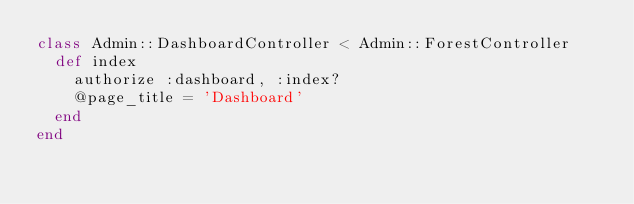Convert code to text. <code><loc_0><loc_0><loc_500><loc_500><_Ruby_>class Admin::DashboardController < Admin::ForestController
  def index
    authorize :dashboard, :index?
    @page_title = 'Dashboard'
  end
end
</code> 